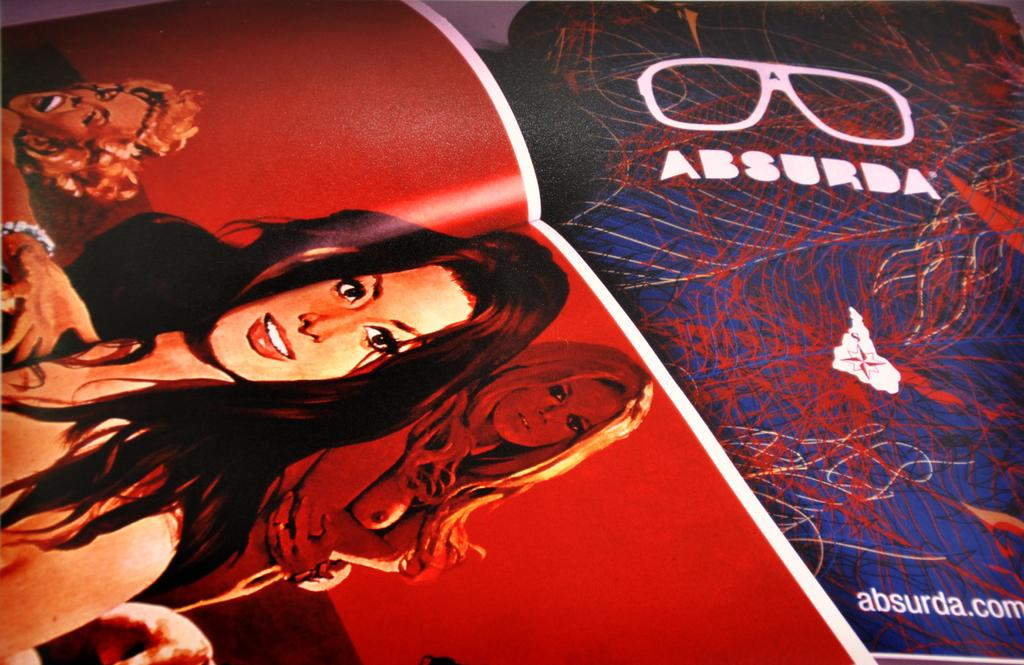What is the main object in the image? There is a magazine in the image. What can be seen on the cover of the magazine? There is a depiction of women on the magazine. What else is visible on the right side of the image? There is a depiction of glasses on the right side of the image. What can be found within the magazine? There is text visible in the image. What type of animal can be seen interacting with the glasses in the image? There is no animal present in the image, and the glasses are not interacting with any object. How many divisions are visible in the magazine in the image? The image does not show any divisions within the magazine; it only shows the cover and a small portion of the right side. 